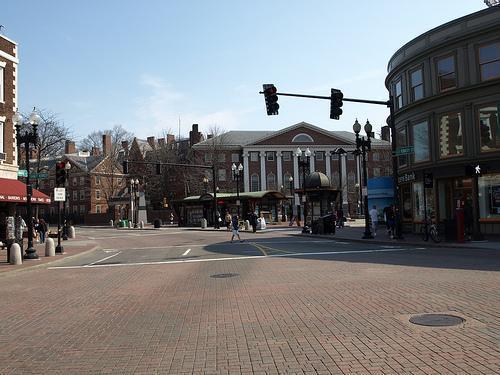How many traffic lights are in the photo?
Give a very brief answer. 5. How many people are riding bike on the road?
Give a very brief answer. 0. 